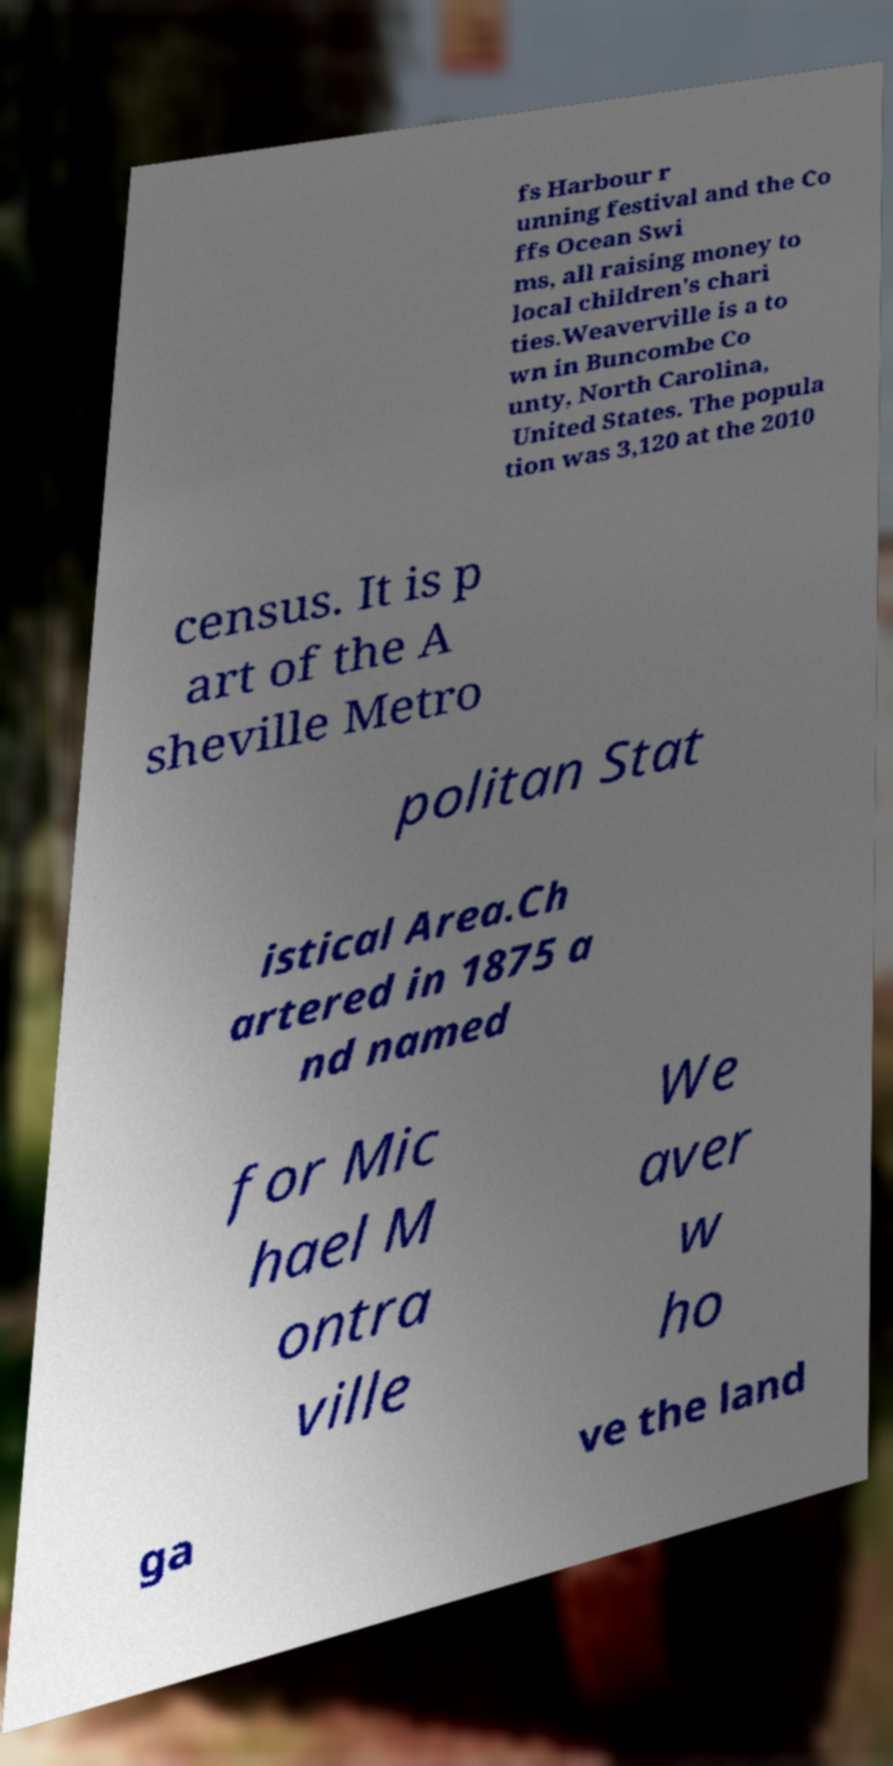Can you accurately transcribe the text from the provided image for me? fs Harbour r unning festival and the Co ffs Ocean Swi ms, all raising money to local children's chari ties.Weaverville is a to wn in Buncombe Co unty, North Carolina, United States. The popula tion was 3,120 at the 2010 census. It is p art of the A sheville Metro politan Stat istical Area.Ch artered in 1875 a nd named for Mic hael M ontra ville We aver w ho ga ve the land 